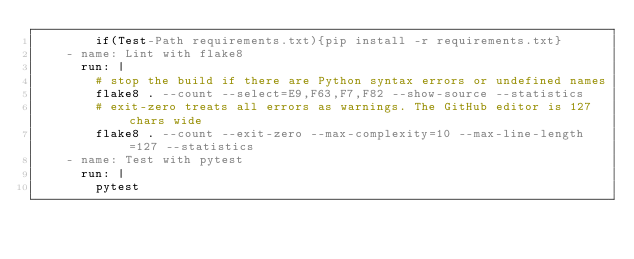<code> <loc_0><loc_0><loc_500><loc_500><_YAML_>        if(Test-Path requirements.txt){pip install -r requirements.txt}
    - name: Lint with flake8
      run: |
        # stop the build if there are Python syntax errors or undefined names
        flake8 . --count --select=E9,F63,F7,F82 --show-source --statistics
        # exit-zero treats all errors as warnings. The GitHub editor is 127 chars wide
        flake8 . --count --exit-zero --max-complexity=10 --max-line-length=127 --statistics
    - name: Test with pytest
      run: |
        pytest
</code> 